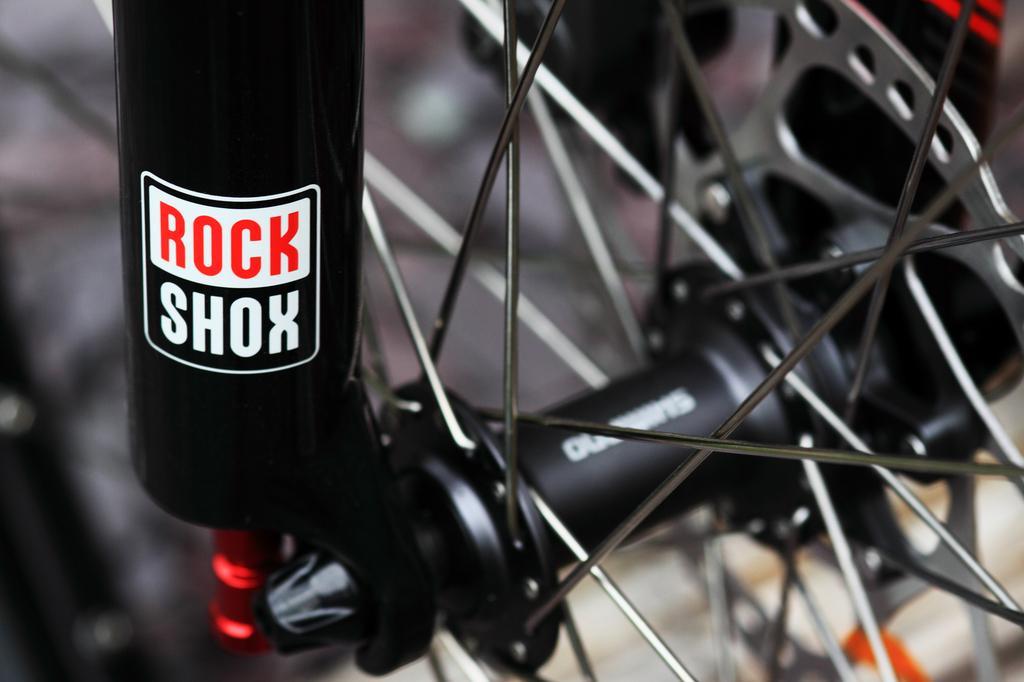In one or two sentences, can you explain what this image depicts? In this image we can see a wheel of a vehicle. There is a black object attached to the wheel. 